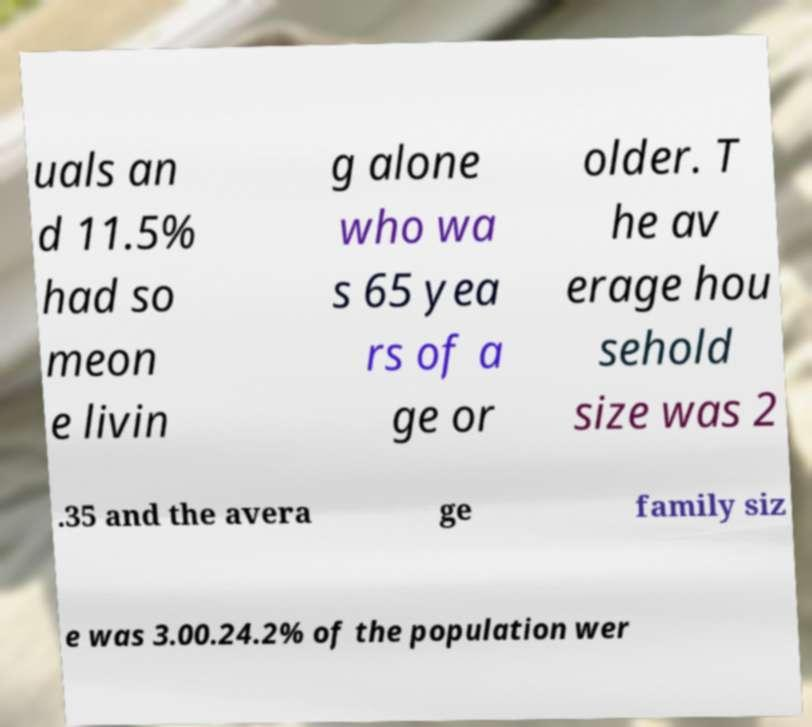Please read and relay the text visible in this image. What does it say? uals an d 11.5% had so meon e livin g alone who wa s 65 yea rs of a ge or older. T he av erage hou sehold size was 2 .35 and the avera ge family siz e was 3.00.24.2% of the population wer 